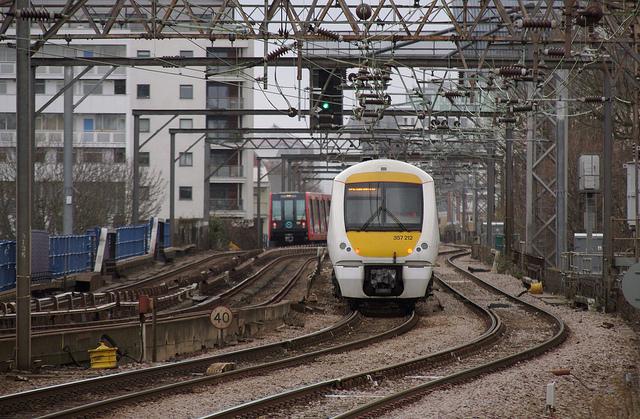What color is the stoplight on?
Concise answer only. Green. Does this area use a lot of train travel?
Concise answer only. Yes. Are the signal light and the front of the train the same color?
Be succinct. No. What speed is the train going?
Concise answer only. 40. How many trains are there?
Write a very short answer. 2. How many trains are visible?
Give a very brief answer. 2. 